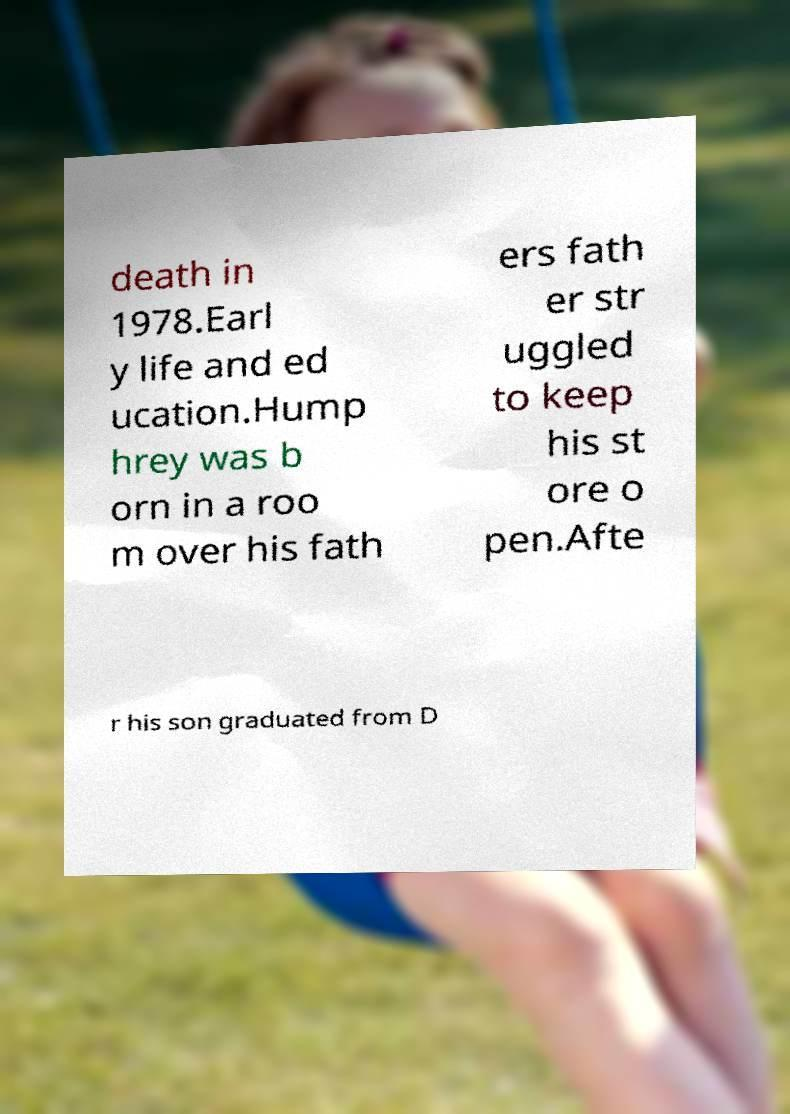What messages or text are displayed in this image? I need them in a readable, typed format. death in 1978.Earl y life and ed ucation.Hump hrey was b orn in a roo m over his fath ers fath er str uggled to keep his st ore o pen.Afte r his son graduated from D 